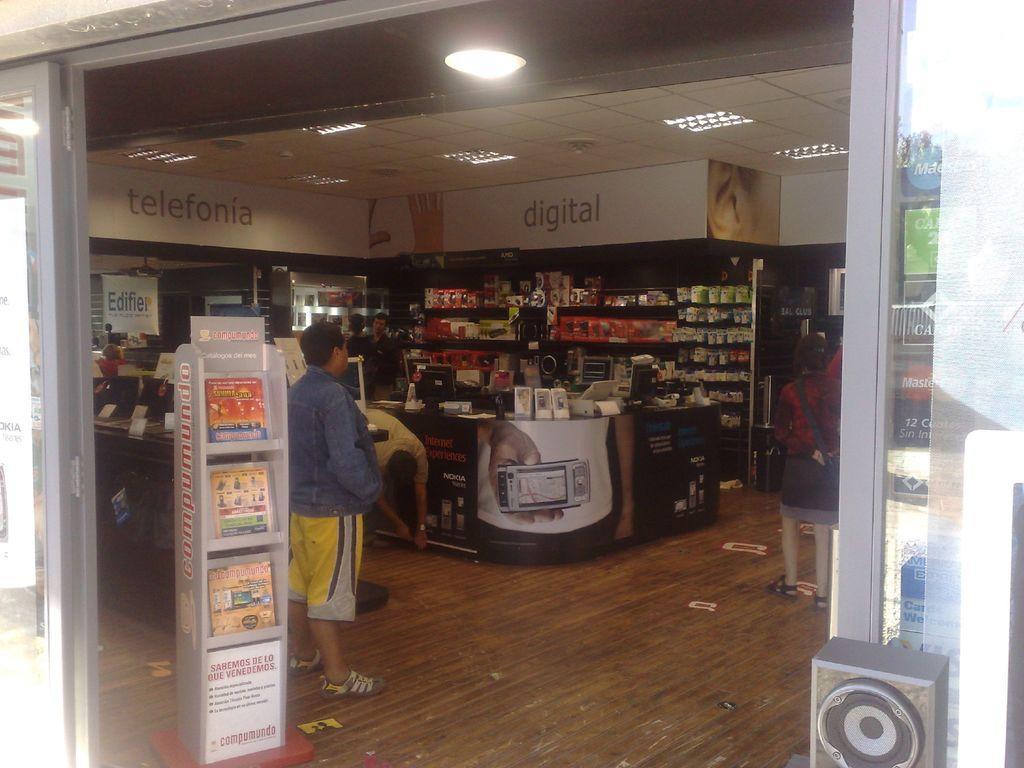In one or two sentences, can you explain what this image depicts? This looks like a store. There are three people standing. These are the magazines placed in the rack. I can see objects placed in an order. These are the computers placed on the desk. This is the poster attached to the wall. These are the ceiling lights attached to the rooftop. At background I can see two people standing. This is the speaker. This looks like a wooden floor. 